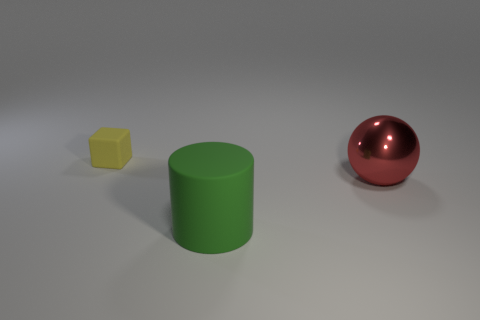Add 3 rubber objects. How many objects exist? 6 Subtract 0 green blocks. How many objects are left? 3 Subtract all cylinders. How many objects are left? 2 Subtract all blue cylinders. Subtract all gray blocks. How many cylinders are left? 1 Subtract all big green objects. Subtract all yellow things. How many objects are left? 1 Add 2 large green objects. How many large green objects are left? 3 Add 1 big red things. How many big red things exist? 2 